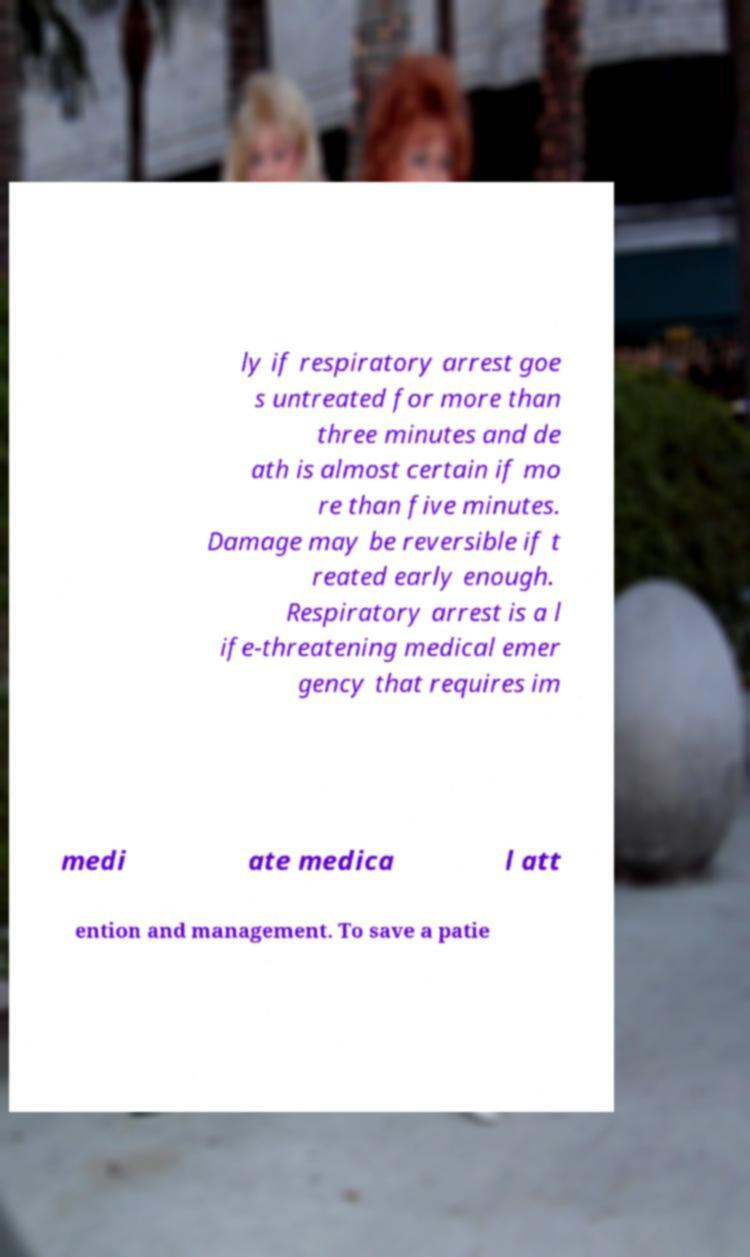I need the written content from this picture converted into text. Can you do that? ly if respiratory arrest goe s untreated for more than three minutes and de ath is almost certain if mo re than five minutes. Damage may be reversible if t reated early enough. Respiratory arrest is a l ife-threatening medical emer gency that requires im medi ate medica l att ention and management. To save a patie 